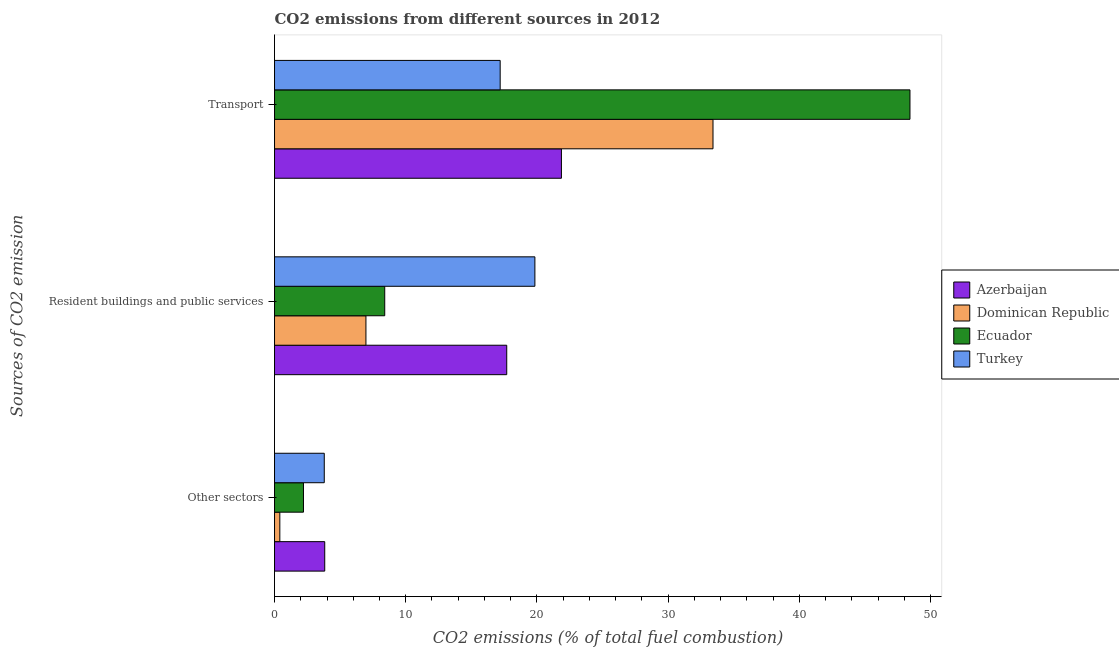How many different coloured bars are there?
Offer a very short reply. 4. How many bars are there on the 2nd tick from the top?
Your response must be concise. 4. What is the label of the 2nd group of bars from the top?
Keep it short and to the point. Resident buildings and public services. What is the percentage of co2 emissions from transport in Azerbaijan?
Offer a terse response. 21.87. Across all countries, what is the maximum percentage of co2 emissions from transport?
Keep it short and to the point. 48.43. Across all countries, what is the minimum percentage of co2 emissions from transport?
Your answer should be compact. 17.2. In which country was the percentage of co2 emissions from resident buildings and public services maximum?
Offer a very short reply. Turkey. In which country was the percentage of co2 emissions from resident buildings and public services minimum?
Give a very brief answer. Dominican Republic. What is the total percentage of co2 emissions from transport in the graph?
Your response must be concise. 120.91. What is the difference between the percentage of co2 emissions from transport in Ecuador and that in Dominican Republic?
Provide a short and direct response. 15.01. What is the difference between the percentage of co2 emissions from other sectors in Azerbaijan and the percentage of co2 emissions from transport in Dominican Republic?
Give a very brief answer. -29.59. What is the average percentage of co2 emissions from other sectors per country?
Give a very brief answer. 2.56. What is the difference between the percentage of co2 emissions from resident buildings and public services and percentage of co2 emissions from transport in Ecuador?
Offer a terse response. -40.03. In how many countries, is the percentage of co2 emissions from other sectors greater than 28 %?
Provide a succinct answer. 0. What is the ratio of the percentage of co2 emissions from resident buildings and public services in Azerbaijan to that in Turkey?
Provide a short and direct response. 0.89. Is the percentage of co2 emissions from other sectors in Turkey less than that in Dominican Republic?
Your answer should be very brief. No. Is the difference between the percentage of co2 emissions from other sectors in Ecuador and Dominican Republic greater than the difference between the percentage of co2 emissions from transport in Ecuador and Dominican Republic?
Make the answer very short. No. What is the difference between the highest and the second highest percentage of co2 emissions from transport?
Keep it short and to the point. 15.01. What is the difference between the highest and the lowest percentage of co2 emissions from resident buildings and public services?
Your answer should be compact. 12.88. In how many countries, is the percentage of co2 emissions from transport greater than the average percentage of co2 emissions from transport taken over all countries?
Make the answer very short. 2. What does the 2nd bar from the top in Other sectors represents?
Provide a short and direct response. Ecuador. What does the 3rd bar from the bottom in Other sectors represents?
Provide a succinct answer. Ecuador. Is it the case that in every country, the sum of the percentage of co2 emissions from other sectors and percentage of co2 emissions from resident buildings and public services is greater than the percentage of co2 emissions from transport?
Your answer should be very brief. No. Are all the bars in the graph horizontal?
Give a very brief answer. Yes. How many countries are there in the graph?
Give a very brief answer. 4. Does the graph contain any zero values?
Your answer should be very brief. No. Does the graph contain grids?
Your answer should be compact. No. Where does the legend appear in the graph?
Your answer should be compact. Center right. How are the legend labels stacked?
Your answer should be compact. Vertical. What is the title of the graph?
Your answer should be compact. CO2 emissions from different sources in 2012. Does "Yemen, Rep." appear as one of the legend labels in the graph?
Offer a terse response. No. What is the label or title of the X-axis?
Provide a short and direct response. CO2 emissions (% of total fuel combustion). What is the label or title of the Y-axis?
Offer a terse response. Sources of CO2 emission. What is the CO2 emissions (% of total fuel combustion) in Azerbaijan in Other sectors?
Give a very brief answer. 3.83. What is the CO2 emissions (% of total fuel combustion) of Dominican Republic in Other sectors?
Ensure brevity in your answer.  0.4. What is the CO2 emissions (% of total fuel combustion) in Ecuador in Other sectors?
Your answer should be compact. 2.21. What is the CO2 emissions (% of total fuel combustion) in Turkey in Other sectors?
Ensure brevity in your answer.  3.79. What is the CO2 emissions (% of total fuel combustion) of Azerbaijan in Resident buildings and public services?
Your answer should be compact. 17.7. What is the CO2 emissions (% of total fuel combustion) of Dominican Republic in Resident buildings and public services?
Make the answer very short. 6.97. What is the CO2 emissions (% of total fuel combustion) of Ecuador in Resident buildings and public services?
Provide a short and direct response. 8.4. What is the CO2 emissions (% of total fuel combustion) of Turkey in Resident buildings and public services?
Offer a terse response. 19.84. What is the CO2 emissions (% of total fuel combustion) in Azerbaijan in Transport?
Provide a short and direct response. 21.87. What is the CO2 emissions (% of total fuel combustion) in Dominican Republic in Transport?
Your answer should be very brief. 33.42. What is the CO2 emissions (% of total fuel combustion) of Ecuador in Transport?
Ensure brevity in your answer.  48.43. What is the CO2 emissions (% of total fuel combustion) in Turkey in Transport?
Make the answer very short. 17.2. Across all Sources of CO2 emission, what is the maximum CO2 emissions (% of total fuel combustion) of Azerbaijan?
Ensure brevity in your answer.  21.87. Across all Sources of CO2 emission, what is the maximum CO2 emissions (% of total fuel combustion) in Dominican Republic?
Offer a terse response. 33.42. Across all Sources of CO2 emission, what is the maximum CO2 emissions (% of total fuel combustion) of Ecuador?
Keep it short and to the point. 48.43. Across all Sources of CO2 emission, what is the maximum CO2 emissions (% of total fuel combustion) in Turkey?
Offer a terse response. 19.84. Across all Sources of CO2 emission, what is the minimum CO2 emissions (% of total fuel combustion) of Azerbaijan?
Offer a terse response. 3.83. Across all Sources of CO2 emission, what is the minimum CO2 emissions (% of total fuel combustion) in Dominican Republic?
Offer a very short reply. 0.4. Across all Sources of CO2 emission, what is the minimum CO2 emissions (% of total fuel combustion) in Ecuador?
Your answer should be very brief. 2.21. Across all Sources of CO2 emission, what is the minimum CO2 emissions (% of total fuel combustion) of Turkey?
Ensure brevity in your answer.  3.79. What is the total CO2 emissions (% of total fuel combustion) of Azerbaijan in the graph?
Keep it short and to the point. 43.39. What is the total CO2 emissions (% of total fuel combustion) in Dominican Republic in the graph?
Provide a short and direct response. 40.79. What is the total CO2 emissions (% of total fuel combustion) in Ecuador in the graph?
Your answer should be very brief. 59.03. What is the total CO2 emissions (% of total fuel combustion) in Turkey in the graph?
Your response must be concise. 40.83. What is the difference between the CO2 emissions (% of total fuel combustion) in Azerbaijan in Other sectors and that in Resident buildings and public services?
Your answer should be very brief. -13.87. What is the difference between the CO2 emissions (% of total fuel combustion) of Dominican Republic in Other sectors and that in Resident buildings and public services?
Ensure brevity in your answer.  -6.56. What is the difference between the CO2 emissions (% of total fuel combustion) of Ecuador in Other sectors and that in Resident buildings and public services?
Make the answer very short. -6.19. What is the difference between the CO2 emissions (% of total fuel combustion) of Turkey in Other sectors and that in Resident buildings and public services?
Your answer should be compact. -16.05. What is the difference between the CO2 emissions (% of total fuel combustion) of Azerbaijan in Other sectors and that in Transport?
Offer a terse response. -18.04. What is the difference between the CO2 emissions (% of total fuel combustion) of Dominican Republic in Other sectors and that in Transport?
Your response must be concise. -33.01. What is the difference between the CO2 emissions (% of total fuel combustion) of Ecuador in Other sectors and that in Transport?
Give a very brief answer. -46.22. What is the difference between the CO2 emissions (% of total fuel combustion) of Turkey in Other sectors and that in Transport?
Provide a short and direct response. -13.41. What is the difference between the CO2 emissions (% of total fuel combustion) of Azerbaijan in Resident buildings and public services and that in Transport?
Ensure brevity in your answer.  -4.17. What is the difference between the CO2 emissions (% of total fuel combustion) in Dominican Republic in Resident buildings and public services and that in Transport?
Offer a very short reply. -26.45. What is the difference between the CO2 emissions (% of total fuel combustion) in Ecuador in Resident buildings and public services and that in Transport?
Your response must be concise. -40.03. What is the difference between the CO2 emissions (% of total fuel combustion) in Turkey in Resident buildings and public services and that in Transport?
Make the answer very short. 2.65. What is the difference between the CO2 emissions (% of total fuel combustion) in Azerbaijan in Other sectors and the CO2 emissions (% of total fuel combustion) in Dominican Republic in Resident buildings and public services?
Keep it short and to the point. -3.14. What is the difference between the CO2 emissions (% of total fuel combustion) in Azerbaijan in Other sectors and the CO2 emissions (% of total fuel combustion) in Ecuador in Resident buildings and public services?
Your answer should be compact. -4.57. What is the difference between the CO2 emissions (% of total fuel combustion) of Azerbaijan in Other sectors and the CO2 emissions (% of total fuel combustion) of Turkey in Resident buildings and public services?
Make the answer very short. -16.02. What is the difference between the CO2 emissions (% of total fuel combustion) of Dominican Republic in Other sectors and the CO2 emissions (% of total fuel combustion) of Ecuador in Resident buildings and public services?
Your answer should be very brief. -8. What is the difference between the CO2 emissions (% of total fuel combustion) in Dominican Republic in Other sectors and the CO2 emissions (% of total fuel combustion) in Turkey in Resident buildings and public services?
Make the answer very short. -19.44. What is the difference between the CO2 emissions (% of total fuel combustion) of Ecuador in Other sectors and the CO2 emissions (% of total fuel combustion) of Turkey in Resident buildings and public services?
Offer a terse response. -17.64. What is the difference between the CO2 emissions (% of total fuel combustion) of Azerbaijan in Other sectors and the CO2 emissions (% of total fuel combustion) of Dominican Republic in Transport?
Your answer should be very brief. -29.59. What is the difference between the CO2 emissions (% of total fuel combustion) of Azerbaijan in Other sectors and the CO2 emissions (% of total fuel combustion) of Ecuador in Transport?
Keep it short and to the point. -44.6. What is the difference between the CO2 emissions (% of total fuel combustion) of Azerbaijan in Other sectors and the CO2 emissions (% of total fuel combustion) of Turkey in Transport?
Give a very brief answer. -13.37. What is the difference between the CO2 emissions (% of total fuel combustion) of Dominican Republic in Other sectors and the CO2 emissions (% of total fuel combustion) of Ecuador in Transport?
Give a very brief answer. -48.03. What is the difference between the CO2 emissions (% of total fuel combustion) in Dominican Republic in Other sectors and the CO2 emissions (% of total fuel combustion) in Turkey in Transport?
Ensure brevity in your answer.  -16.79. What is the difference between the CO2 emissions (% of total fuel combustion) in Ecuador in Other sectors and the CO2 emissions (% of total fuel combustion) in Turkey in Transport?
Your answer should be compact. -14.99. What is the difference between the CO2 emissions (% of total fuel combustion) in Azerbaijan in Resident buildings and public services and the CO2 emissions (% of total fuel combustion) in Dominican Republic in Transport?
Keep it short and to the point. -15.72. What is the difference between the CO2 emissions (% of total fuel combustion) of Azerbaijan in Resident buildings and public services and the CO2 emissions (% of total fuel combustion) of Ecuador in Transport?
Offer a very short reply. -30.73. What is the difference between the CO2 emissions (% of total fuel combustion) of Azerbaijan in Resident buildings and public services and the CO2 emissions (% of total fuel combustion) of Turkey in Transport?
Your answer should be very brief. 0.5. What is the difference between the CO2 emissions (% of total fuel combustion) of Dominican Republic in Resident buildings and public services and the CO2 emissions (% of total fuel combustion) of Ecuador in Transport?
Ensure brevity in your answer.  -41.46. What is the difference between the CO2 emissions (% of total fuel combustion) in Dominican Republic in Resident buildings and public services and the CO2 emissions (% of total fuel combustion) in Turkey in Transport?
Provide a succinct answer. -10.23. What is the difference between the CO2 emissions (% of total fuel combustion) of Ecuador in Resident buildings and public services and the CO2 emissions (% of total fuel combustion) of Turkey in Transport?
Provide a succinct answer. -8.8. What is the average CO2 emissions (% of total fuel combustion) of Azerbaijan per Sources of CO2 emission?
Offer a terse response. 14.46. What is the average CO2 emissions (% of total fuel combustion) of Dominican Republic per Sources of CO2 emission?
Provide a succinct answer. 13.6. What is the average CO2 emissions (% of total fuel combustion) of Ecuador per Sources of CO2 emission?
Your response must be concise. 19.68. What is the average CO2 emissions (% of total fuel combustion) in Turkey per Sources of CO2 emission?
Offer a terse response. 13.61. What is the difference between the CO2 emissions (% of total fuel combustion) of Azerbaijan and CO2 emissions (% of total fuel combustion) of Dominican Republic in Other sectors?
Your answer should be compact. 3.42. What is the difference between the CO2 emissions (% of total fuel combustion) of Azerbaijan and CO2 emissions (% of total fuel combustion) of Ecuador in Other sectors?
Provide a succinct answer. 1.62. What is the difference between the CO2 emissions (% of total fuel combustion) in Azerbaijan and CO2 emissions (% of total fuel combustion) in Turkey in Other sectors?
Your answer should be compact. 0.04. What is the difference between the CO2 emissions (% of total fuel combustion) of Dominican Republic and CO2 emissions (% of total fuel combustion) of Ecuador in Other sectors?
Ensure brevity in your answer.  -1.8. What is the difference between the CO2 emissions (% of total fuel combustion) of Dominican Republic and CO2 emissions (% of total fuel combustion) of Turkey in Other sectors?
Provide a succinct answer. -3.39. What is the difference between the CO2 emissions (% of total fuel combustion) in Ecuador and CO2 emissions (% of total fuel combustion) in Turkey in Other sectors?
Offer a terse response. -1.58. What is the difference between the CO2 emissions (% of total fuel combustion) of Azerbaijan and CO2 emissions (% of total fuel combustion) of Dominican Republic in Resident buildings and public services?
Keep it short and to the point. 10.73. What is the difference between the CO2 emissions (% of total fuel combustion) in Azerbaijan and CO2 emissions (% of total fuel combustion) in Ecuador in Resident buildings and public services?
Offer a very short reply. 9.3. What is the difference between the CO2 emissions (% of total fuel combustion) of Azerbaijan and CO2 emissions (% of total fuel combustion) of Turkey in Resident buildings and public services?
Your answer should be compact. -2.15. What is the difference between the CO2 emissions (% of total fuel combustion) in Dominican Republic and CO2 emissions (% of total fuel combustion) in Ecuador in Resident buildings and public services?
Make the answer very short. -1.43. What is the difference between the CO2 emissions (% of total fuel combustion) in Dominican Republic and CO2 emissions (% of total fuel combustion) in Turkey in Resident buildings and public services?
Ensure brevity in your answer.  -12.88. What is the difference between the CO2 emissions (% of total fuel combustion) of Ecuador and CO2 emissions (% of total fuel combustion) of Turkey in Resident buildings and public services?
Offer a very short reply. -11.44. What is the difference between the CO2 emissions (% of total fuel combustion) in Azerbaijan and CO2 emissions (% of total fuel combustion) in Dominican Republic in Transport?
Give a very brief answer. -11.55. What is the difference between the CO2 emissions (% of total fuel combustion) of Azerbaijan and CO2 emissions (% of total fuel combustion) of Ecuador in Transport?
Your response must be concise. -26.56. What is the difference between the CO2 emissions (% of total fuel combustion) in Azerbaijan and CO2 emissions (% of total fuel combustion) in Turkey in Transport?
Your answer should be very brief. 4.67. What is the difference between the CO2 emissions (% of total fuel combustion) in Dominican Republic and CO2 emissions (% of total fuel combustion) in Ecuador in Transport?
Provide a succinct answer. -15.01. What is the difference between the CO2 emissions (% of total fuel combustion) in Dominican Republic and CO2 emissions (% of total fuel combustion) in Turkey in Transport?
Your response must be concise. 16.22. What is the difference between the CO2 emissions (% of total fuel combustion) in Ecuador and CO2 emissions (% of total fuel combustion) in Turkey in Transport?
Offer a terse response. 31.23. What is the ratio of the CO2 emissions (% of total fuel combustion) of Azerbaijan in Other sectors to that in Resident buildings and public services?
Make the answer very short. 0.22. What is the ratio of the CO2 emissions (% of total fuel combustion) in Dominican Republic in Other sectors to that in Resident buildings and public services?
Your answer should be compact. 0.06. What is the ratio of the CO2 emissions (% of total fuel combustion) of Ecuador in Other sectors to that in Resident buildings and public services?
Make the answer very short. 0.26. What is the ratio of the CO2 emissions (% of total fuel combustion) of Turkey in Other sectors to that in Resident buildings and public services?
Provide a short and direct response. 0.19. What is the ratio of the CO2 emissions (% of total fuel combustion) of Azerbaijan in Other sectors to that in Transport?
Offer a very short reply. 0.17. What is the ratio of the CO2 emissions (% of total fuel combustion) in Dominican Republic in Other sectors to that in Transport?
Give a very brief answer. 0.01. What is the ratio of the CO2 emissions (% of total fuel combustion) in Ecuador in Other sectors to that in Transport?
Give a very brief answer. 0.05. What is the ratio of the CO2 emissions (% of total fuel combustion) of Turkey in Other sectors to that in Transport?
Keep it short and to the point. 0.22. What is the ratio of the CO2 emissions (% of total fuel combustion) of Azerbaijan in Resident buildings and public services to that in Transport?
Provide a short and direct response. 0.81. What is the ratio of the CO2 emissions (% of total fuel combustion) of Dominican Republic in Resident buildings and public services to that in Transport?
Your response must be concise. 0.21. What is the ratio of the CO2 emissions (% of total fuel combustion) of Ecuador in Resident buildings and public services to that in Transport?
Your answer should be very brief. 0.17. What is the ratio of the CO2 emissions (% of total fuel combustion) of Turkey in Resident buildings and public services to that in Transport?
Provide a succinct answer. 1.15. What is the difference between the highest and the second highest CO2 emissions (% of total fuel combustion) in Azerbaijan?
Ensure brevity in your answer.  4.17. What is the difference between the highest and the second highest CO2 emissions (% of total fuel combustion) in Dominican Republic?
Provide a short and direct response. 26.45. What is the difference between the highest and the second highest CO2 emissions (% of total fuel combustion) in Ecuador?
Give a very brief answer. 40.03. What is the difference between the highest and the second highest CO2 emissions (% of total fuel combustion) in Turkey?
Give a very brief answer. 2.65. What is the difference between the highest and the lowest CO2 emissions (% of total fuel combustion) in Azerbaijan?
Your response must be concise. 18.04. What is the difference between the highest and the lowest CO2 emissions (% of total fuel combustion) in Dominican Republic?
Keep it short and to the point. 33.01. What is the difference between the highest and the lowest CO2 emissions (% of total fuel combustion) of Ecuador?
Your answer should be very brief. 46.22. What is the difference between the highest and the lowest CO2 emissions (% of total fuel combustion) in Turkey?
Your answer should be very brief. 16.05. 